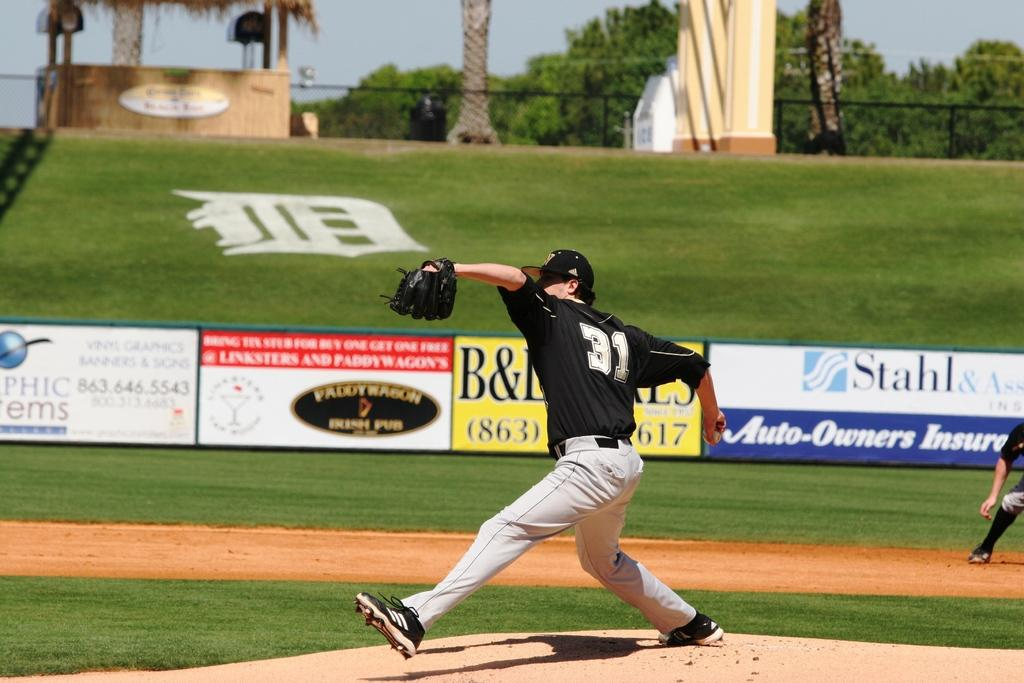<image>
Create a compact narrative representing the image presented. A baseball throws a pitch at a field sponsored by Paddywagon Irish Pub. 